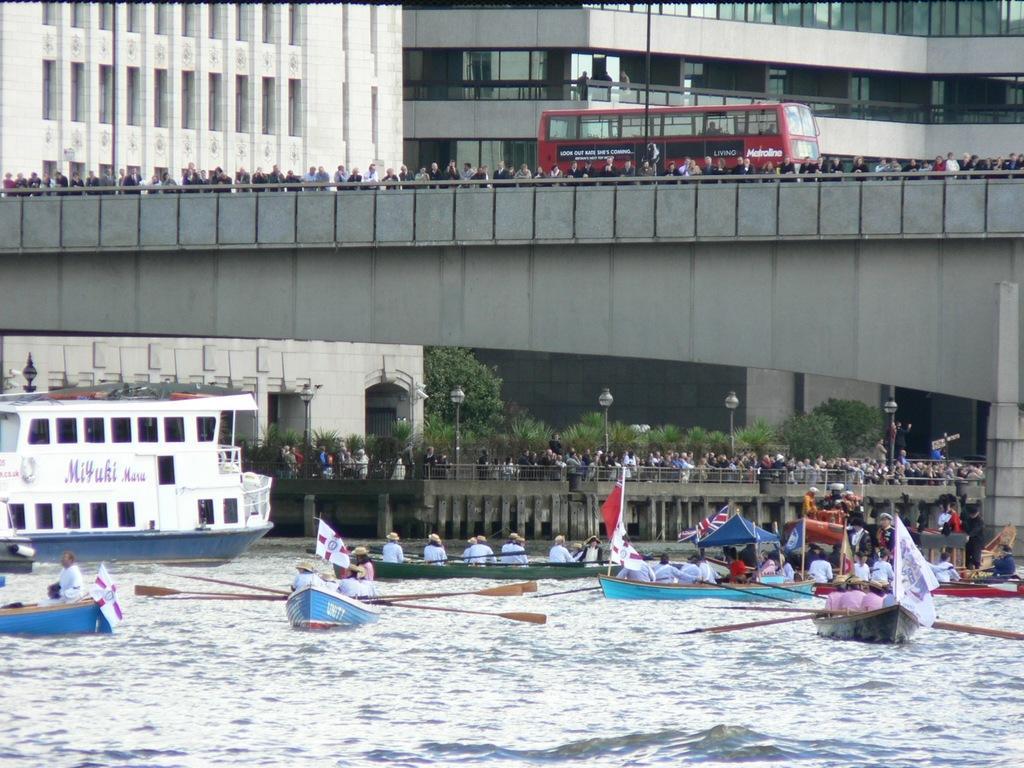Describe this image in one or two sentences. At the bottom of the image there is water. There are people sitting in boats. In the background of the image there are buildings. There is a bridge on which there are people standing. There is a red color bus. There is a pole. There is another bridge on which there are people standing. There are plants, trees. To the left side of the image there is ship. 